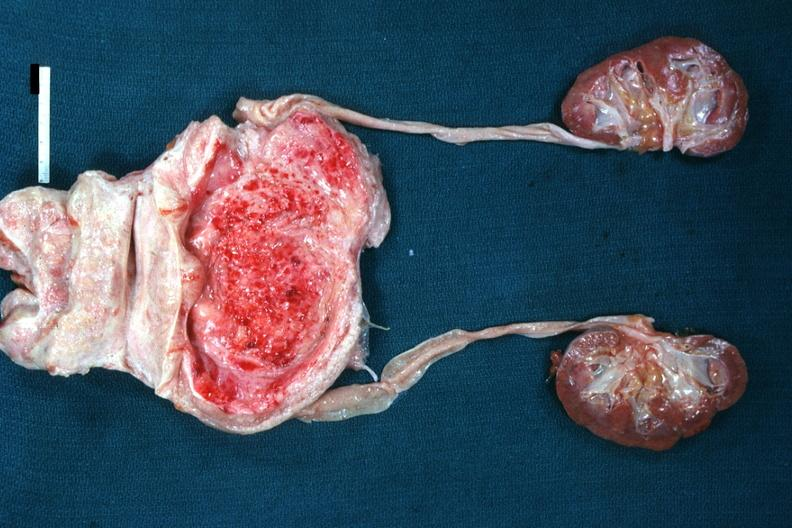s prostate present?
Answer the question using a single word or phrase. Yes 